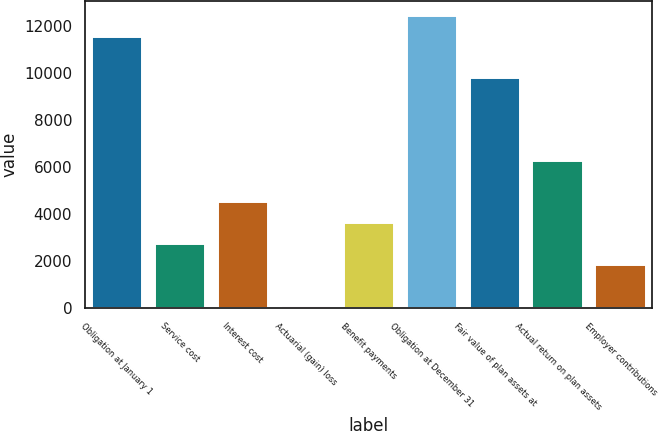<chart> <loc_0><loc_0><loc_500><loc_500><bar_chart><fcel>Obligation at January 1<fcel>Service cost<fcel>Interest cost<fcel>Actuarial (gain) loss<fcel>Benefit payments<fcel>Obligation at December 31<fcel>Fair value of plan assets at<fcel>Actual return on plan assets<fcel>Employer contributions<nl><fcel>11533.4<fcel>2735.4<fcel>4495<fcel>96<fcel>3615.2<fcel>12413.2<fcel>9773.8<fcel>6254.6<fcel>1855.6<nl></chart> 